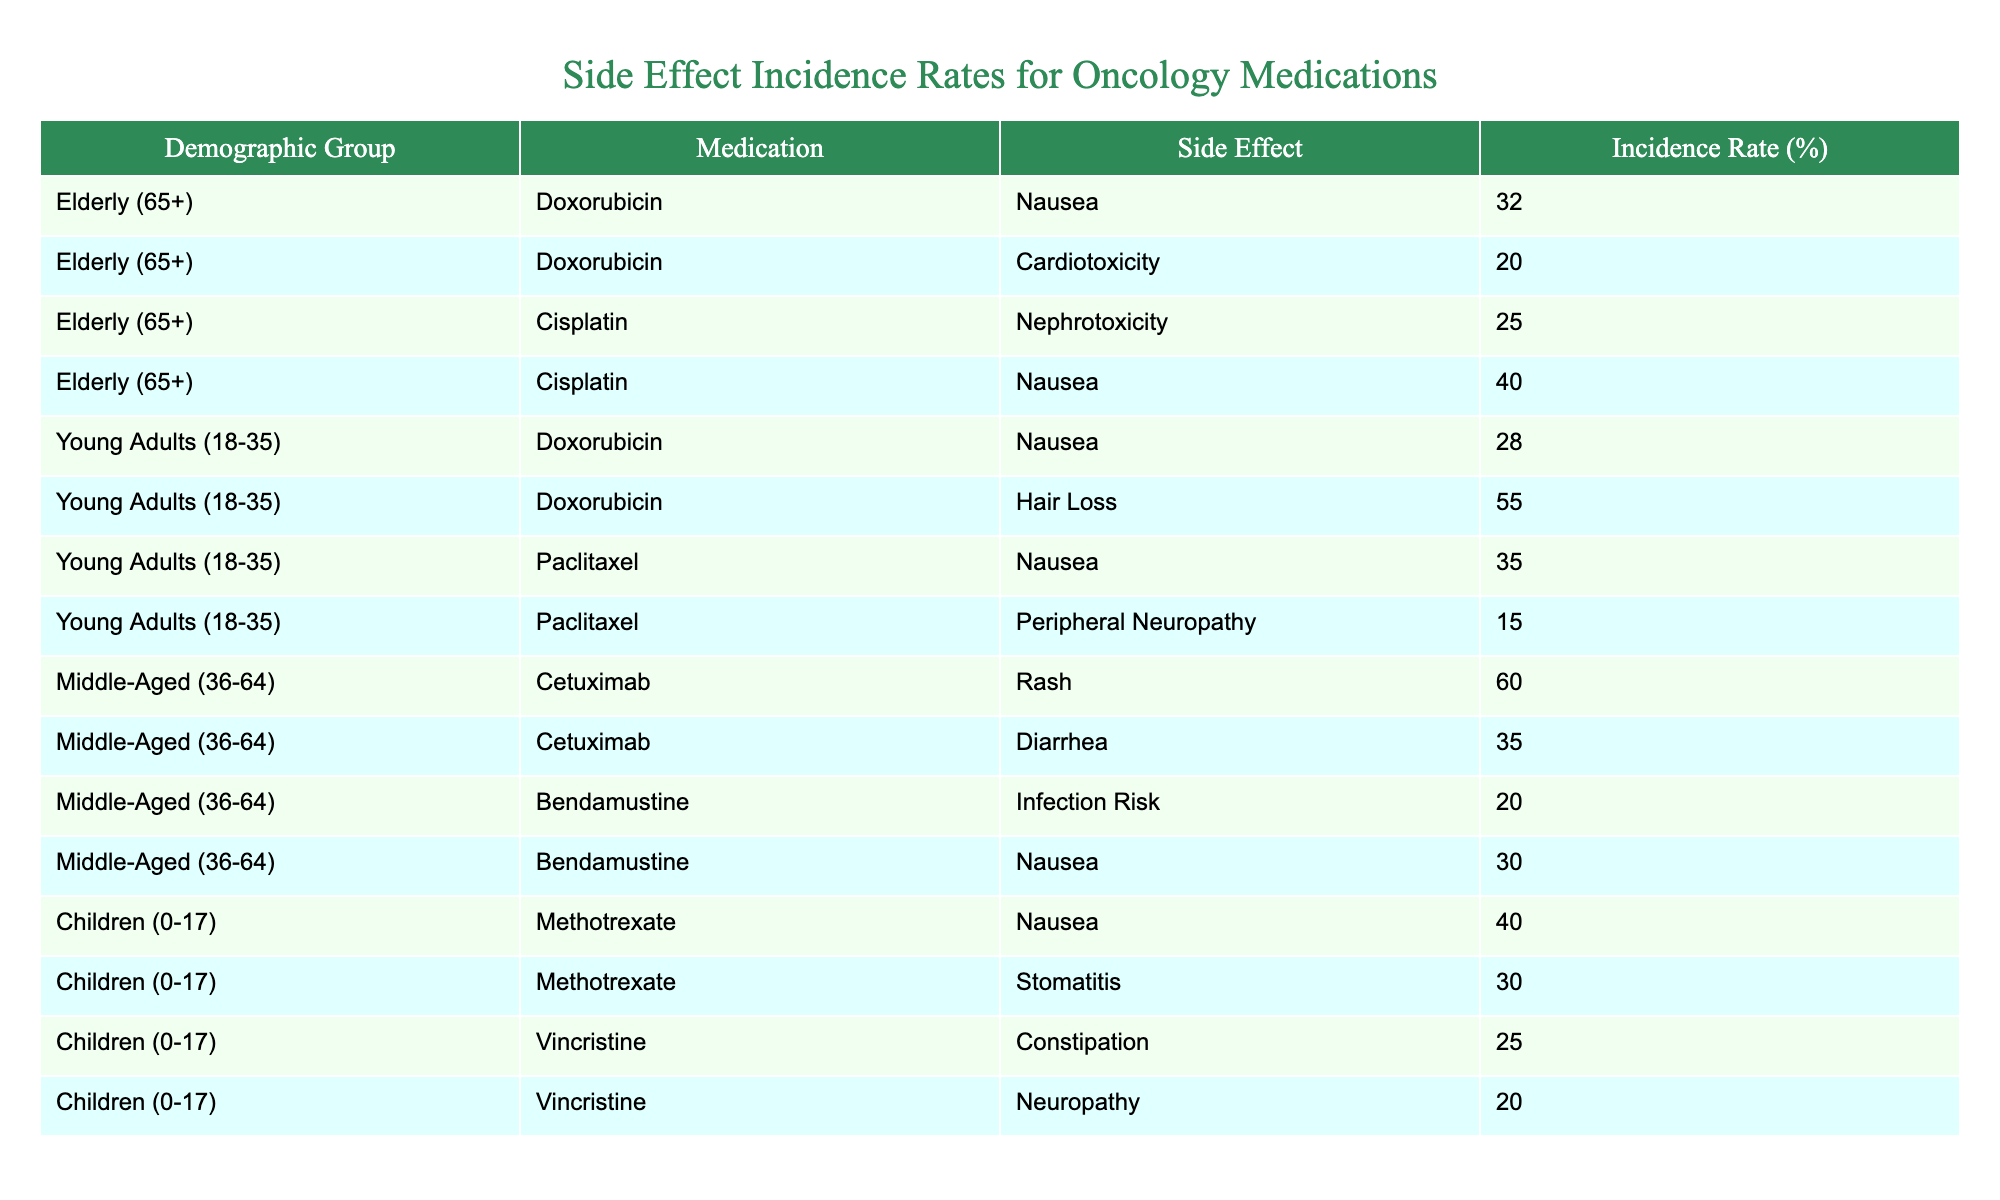What is the incidence rate of nausea for elderly patients taking Doxorubicin? The table shows that for the elderly demographic group taking Doxorubicin, the incidence rate for nausea is listed as 32%.
Answer: 32% Which medication has the highest incidence rate of hair loss among young adults? According to the table, Doxorubicin has the highest incidence rate of hair loss among young adults at 55%.
Answer: Doxorubicin What is the total incidence rate of nausea across all demographic groups? To find the total incidence rate of nausea, we add the rates for each group: Elderly (Doxorubicin 32% + Cisplatin 40%), Young Adults (Doxorubicin 28% + Paclitaxel 35%), and Children (Methotrexate 40%). This totals to 32 + 40 + 28 + 35 + 40 = 175%.
Answer: 175% Is the incidence rate of cardiotoxicity higher than that of nephrotoxicity for elderly patients taking Doxorubicin and Cisplatin respectively? Yes, the incidence rate of cardiotoxicity for elderly patients taking Doxorubicin is 20%, which is lower than the nephrotoxicity rate for Cisplatin at 25%.
Answer: No Which demographic group experiences the highest incidence rate of rash, and what is that rate? Middle-aged patients taking Cetuximab experience the highest incidence rate of rash at 60%, which is listed in the table.
Answer: 60% 